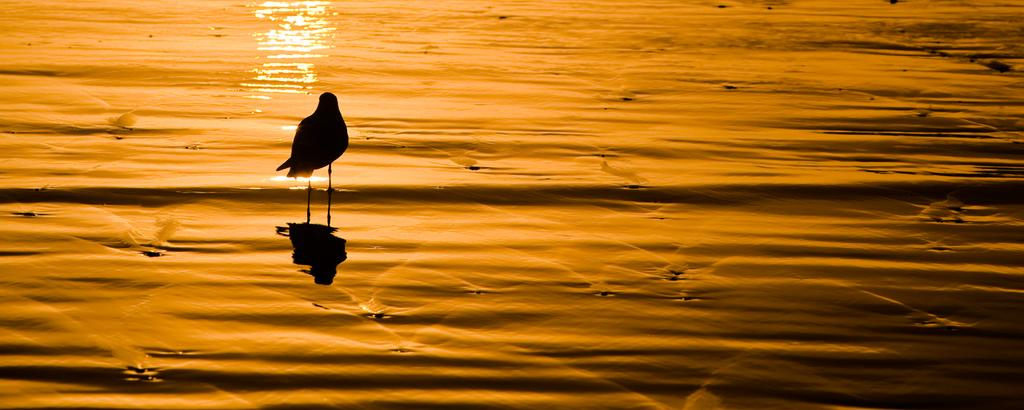What type of animal is in the image? There is a bird in the image. What color is the bird? The bird is black in color. Where is the bird located in the image? The bird is in the water. Can you describe the lighting in the image? The image might have been taken at sunset, suggesting a warm, orange-tinted light. How many feathers does the bird have on its nerve in the image? There is no mention of feathers or nerves in the image, and therefore it is not possible to answer this question. 